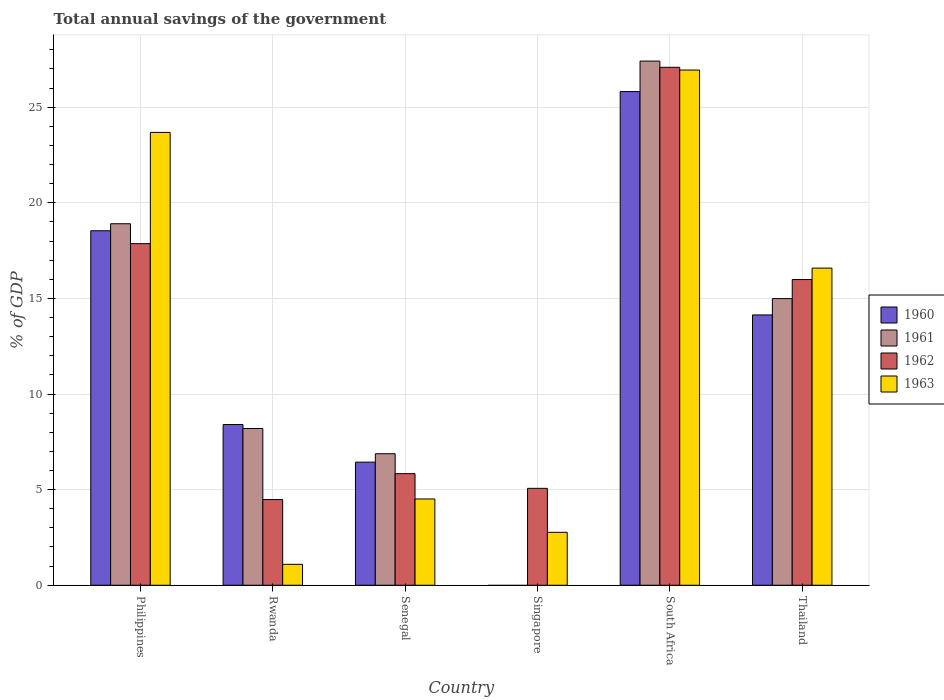How many different coloured bars are there?
Offer a terse response. 4. How many groups of bars are there?
Your answer should be very brief. 6. Are the number of bars on each tick of the X-axis equal?
Your answer should be very brief. No. How many bars are there on the 5th tick from the right?
Provide a succinct answer. 4. What is the label of the 5th group of bars from the left?
Ensure brevity in your answer.  South Africa. In how many cases, is the number of bars for a given country not equal to the number of legend labels?
Your response must be concise. 1. What is the total annual savings of the government in 1962 in Singapore?
Offer a terse response. 5.07. Across all countries, what is the maximum total annual savings of the government in 1962?
Your answer should be very brief. 27.08. Across all countries, what is the minimum total annual savings of the government in 1963?
Give a very brief answer. 1.09. In which country was the total annual savings of the government in 1961 maximum?
Offer a very short reply. South Africa. What is the total total annual savings of the government in 1963 in the graph?
Make the answer very short. 75.57. What is the difference between the total annual savings of the government in 1960 in Philippines and that in Senegal?
Your response must be concise. 12.1. What is the difference between the total annual savings of the government in 1961 in Singapore and the total annual savings of the government in 1960 in Rwanda?
Offer a very short reply. -8.4. What is the average total annual savings of the government in 1960 per country?
Make the answer very short. 12.22. What is the difference between the total annual savings of the government of/in 1961 and total annual savings of the government of/in 1962 in South Africa?
Your answer should be very brief. 0.33. What is the ratio of the total annual savings of the government in 1960 in Philippines to that in Thailand?
Provide a short and direct response. 1.31. Is the total annual savings of the government in 1961 in Philippines less than that in Rwanda?
Ensure brevity in your answer.  No. Is the difference between the total annual savings of the government in 1961 in Rwanda and Senegal greater than the difference between the total annual savings of the government in 1962 in Rwanda and Senegal?
Make the answer very short. Yes. What is the difference between the highest and the second highest total annual savings of the government in 1961?
Your response must be concise. -8.51. What is the difference between the highest and the lowest total annual savings of the government in 1962?
Keep it short and to the point. 22.6. In how many countries, is the total annual savings of the government in 1962 greater than the average total annual savings of the government in 1962 taken over all countries?
Your answer should be very brief. 3. Is the sum of the total annual savings of the government in 1962 in Rwanda and South Africa greater than the maximum total annual savings of the government in 1960 across all countries?
Keep it short and to the point. Yes. Is it the case that in every country, the sum of the total annual savings of the government in 1962 and total annual savings of the government in 1961 is greater than the sum of total annual savings of the government in 1963 and total annual savings of the government in 1960?
Offer a very short reply. No. How many bars are there?
Make the answer very short. 22. Are all the bars in the graph horizontal?
Provide a succinct answer. No. Does the graph contain any zero values?
Give a very brief answer. Yes. Does the graph contain grids?
Your answer should be very brief. Yes. How many legend labels are there?
Your answer should be compact. 4. What is the title of the graph?
Your response must be concise. Total annual savings of the government. Does "2002" appear as one of the legend labels in the graph?
Give a very brief answer. No. What is the label or title of the Y-axis?
Ensure brevity in your answer.  % of GDP. What is the % of GDP of 1960 in Philippines?
Your response must be concise. 18.54. What is the % of GDP of 1961 in Philippines?
Provide a short and direct response. 18.9. What is the % of GDP of 1962 in Philippines?
Your answer should be very brief. 17.86. What is the % of GDP of 1963 in Philippines?
Your answer should be compact. 23.68. What is the % of GDP of 1960 in Rwanda?
Provide a short and direct response. 8.4. What is the % of GDP of 1961 in Rwanda?
Your answer should be compact. 8.2. What is the % of GDP of 1962 in Rwanda?
Keep it short and to the point. 4.48. What is the % of GDP in 1963 in Rwanda?
Your response must be concise. 1.09. What is the % of GDP of 1960 in Senegal?
Give a very brief answer. 6.44. What is the % of GDP in 1961 in Senegal?
Ensure brevity in your answer.  6.88. What is the % of GDP in 1962 in Senegal?
Offer a very short reply. 5.83. What is the % of GDP of 1963 in Senegal?
Offer a very short reply. 4.51. What is the % of GDP in 1960 in Singapore?
Your answer should be very brief. 0. What is the % of GDP of 1961 in Singapore?
Keep it short and to the point. 0. What is the % of GDP of 1962 in Singapore?
Keep it short and to the point. 5.07. What is the % of GDP in 1963 in Singapore?
Ensure brevity in your answer.  2.77. What is the % of GDP in 1960 in South Africa?
Keep it short and to the point. 25.81. What is the % of GDP of 1961 in South Africa?
Offer a very short reply. 27.41. What is the % of GDP of 1962 in South Africa?
Give a very brief answer. 27.08. What is the % of GDP of 1963 in South Africa?
Ensure brevity in your answer.  26.94. What is the % of GDP in 1960 in Thailand?
Provide a succinct answer. 14.13. What is the % of GDP in 1961 in Thailand?
Offer a very short reply. 14.99. What is the % of GDP in 1962 in Thailand?
Provide a short and direct response. 15.99. What is the % of GDP in 1963 in Thailand?
Your response must be concise. 16.58. Across all countries, what is the maximum % of GDP in 1960?
Your answer should be compact. 25.81. Across all countries, what is the maximum % of GDP in 1961?
Ensure brevity in your answer.  27.41. Across all countries, what is the maximum % of GDP in 1962?
Your answer should be very brief. 27.08. Across all countries, what is the maximum % of GDP of 1963?
Your response must be concise. 26.94. Across all countries, what is the minimum % of GDP in 1960?
Give a very brief answer. 0. Across all countries, what is the minimum % of GDP in 1961?
Give a very brief answer. 0. Across all countries, what is the minimum % of GDP in 1962?
Your response must be concise. 4.48. Across all countries, what is the minimum % of GDP of 1963?
Offer a terse response. 1.09. What is the total % of GDP of 1960 in the graph?
Offer a very short reply. 73.33. What is the total % of GDP of 1961 in the graph?
Offer a very short reply. 76.37. What is the total % of GDP of 1962 in the graph?
Provide a short and direct response. 76.31. What is the total % of GDP of 1963 in the graph?
Your answer should be compact. 75.57. What is the difference between the % of GDP of 1960 in Philippines and that in Rwanda?
Give a very brief answer. 10.13. What is the difference between the % of GDP in 1961 in Philippines and that in Rwanda?
Make the answer very short. 10.71. What is the difference between the % of GDP of 1962 in Philippines and that in Rwanda?
Ensure brevity in your answer.  13.38. What is the difference between the % of GDP of 1963 in Philippines and that in Rwanda?
Offer a terse response. 22.58. What is the difference between the % of GDP in 1960 in Philippines and that in Senegal?
Provide a short and direct response. 12.1. What is the difference between the % of GDP of 1961 in Philippines and that in Senegal?
Ensure brevity in your answer.  12.03. What is the difference between the % of GDP of 1962 in Philippines and that in Senegal?
Give a very brief answer. 12.03. What is the difference between the % of GDP in 1963 in Philippines and that in Senegal?
Provide a short and direct response. 19.17. What is the difference between the % of GDP in 1962 in Philippines and that in Singapore?
Provide a short and direct response. 12.79. What is the difference between the % of GDP of 1963 in Philippines and that in Singapore?
Provide a succinct answer. 20.91. What is the difference between the % of GDP of 1960 in Philippines and that in South Africa?
Provide a succinct answer. -7.28. What is the difference between the % of GDP of 1961 in Philippines and that in South Africa?
Give a very brief answer. -8.51. What is the difference between the % of GDP in 1962 in Philippines and that in South Africa?
Your answer should be compact. -9.22. What is the difference between the % of GDP in 1963 in Philippines and that in South Africa?
Keep it short and to the point. -3.26. What is the difference between the % of GDP in 1960 in Philippines and that in Thailand?
Provide a short and direct response. 4.4. What is the difference between the % of GDP of 1961 in Philippines and that in Thailand?
Offer a very short reply. 3.91. What is the difference between the % of GDP of 1962 in Philippines and that in Thailand?
Offer a very short reply. 1.88. What is the difference between the % of GDP of 1963 in Philippines and that in Thailand?
Provide a succinct answer. 7.09. What is the difference between the % of GDP in 1960 in Rwanda and that in Senegal?
Give a very brief answer. 1.97. What is the difference between the % of GDP in 1961 in Rwanda and that in Senegal?
Your response must be concise. 1.32. What is the difference between the % of GDP in 1962 in Rwanda and that in Senegal?
Provide a succinct answer. -1.35. What is the difference between the % of GDP of 1963 in Rwanda and that in Senegal?
Give a very brief answer. -3.42. What is the difference between the % of GDP in 1962 in Rwanda and that in Singapore?
Offer a very short reply. -0.59. What is the difference between the % of GDP in 1963 in Rwanda and that in Singapore?
Offer a very short reply. -1.67. What is the difference between the % of GDP of 1960 in Rwanda and that in South Africa?
Offer a very short reply. -17.41. What is the difference between the % of GDP of 1961 in Rwanda and that in South Africa?
Provide a short and direct response. -19.21. What is the difference between the % of GDP in 1962 in Rwanda and that in South Africa?
Ensure brevity in your answer.  -22.6. What is the difference between the % of GDP of 1963 in Rwanda and that in South Africa?
Make the answer very short. -25.85. What is the difference between the % of GDP in 1960 in Rwanda and that in Thailand?
Offer a terse response. -5.73. What is the difference between the % of GDP of 1961 in Rwanda and that in Thailand?
Give a very brief answer. -6.79. What is the difference between the % of GDP of 1962 in Rwanda and that in Thailand?
Provide a succinct answer. -11.51. What is the difference between the % of GDP in 1963 in Rwanda and that in Thailand?
Your answer should be very brief. -15.49. What is the difference between the % of GDP of 1962 in Senegal and that in Singapore?
Your answer should be very brief. 0.77. What is the difference between the % of GDP of 1963 in Senegal and that in Singapore?
Your answer should be very brief. 1.74. What is the difference between the % of GDP in 1960 in Senegal and that in South Africa?
Offer a very short reply. -19.38. What is the difference between the % of GDP in 1961 in Senegal and that in South Africa?
Your answer should be compact. -20.53. What is the difference between the % of GDP of 1962 in Senegal and that in South Africa?
Your answer should be very brief. -21.25. What is the difference between the % of GDP in 1963 in Senegal and that in South Africa?
Give a very brief answer. -22.43. What is the difference between the % of GDP in 1960 in Senegal and that in Thailand?
Your answer should be compact. -7.7. What is the difference between the % of GDP of 1961 in Senegal and that in Thailand?
Your response must be concise. -8.11. What is the difference between the % of GDP of 1962 in Senegal and that in Thailand?
Your answer should be very brief. -10.15. What is the difference between the % of GDP of 1963 in Senegal and that in Thailand?
Provide a short and direct response. -12.07. What is the difference between the % of GDP of 1962 in Singapore and that in South Africa?
Offer a terse response. -22.02. What is the difference between the % of GDP of 1963 in Singapore and that in South Africa?
Give a very brief answer. -24.17. What is the difference between the % of GDP in 1962 in Singapore and that in Thailand?
Offer a very short reply. -10.92. What is the difference between the % of GDP in 1963 in Singapore and that in Thailand?
Offer a terse response. -13.82. What is the difference between the % of GDP of 1960 in South Africa and that in Thailand?
Offer a very short reply. 11.68. What is the difference between the % of GDP in 1961 in South Africa and that in Thailand?
Provide a short and direct response. 12.42. What is the difference between the % of GDP of 1962 in South Africa and that in Thailand?
Ensure brevity in your answer.  11.1. What is the difference between the % of GDP in 1963 in South Africa and that in Thailand?
Your answer should be very brief. 10.36. What is the difference between the % of GDP of 1960 in Philippines and the % of GDP of 1961 in Rwanda?
Your answer should be compact. 10.34. What is the difference between the % of GDP of 1960 in Philippines and the % of GDP of 1962 in Rwanda?
Offer a very short reply. 14.06. What is the difference between the % of GDP of 1960 in Philippines and the % of GDP of 1963 in Rwanda?
Your answer should be very brief. 17.44. What is the difference between the % of GDP in 1961 in Philippines and the % of GDP in 1962 in Rwanda?
Provide a short and direct response. 14.42. What is the difference between the % of GDP of 1961 in Philippines and the % of GDP of 1963 in Rwanda?
Keep it short and to the point. 17.81. What is the difference between the % of GDP of 1962 in Philippines and the % of GDP of 1963 in Rwanda?
Your answer should be compact. 16.77. What is the difference between the % of GDP in 1960 in Philippines and the % of GDP in 1961 in Senegal?
Offer a terse response. 11.66. What is the difference between the % of GDP in 1960 in Philippines and the % of GDP in 1962 in Senegal?
Give a very brief answer. 12.7. What is the difference between the % of GDP of 1960 in Philippines and the % of GDP of 1963 in Senegal?
Provide a succinct answer. 14.03. What is the difference between the % of GDP of 1961 in Philippines and the % of GDP of 1962 in Senegal?
Make the answer very short. 13.07. What is the difference between the % of GDP of 1961 in Philippines and the % of GDP of 1963 in Senegal?
Your answer should be compact. 14.39. What is the difference between the % of GDP in 1962 in Philippines and the % of GDP in 1963 in Senegal?
Your response must be concise. 13.35. What is the difference between the % of GDP in 1960 in Philippines and the % of GDP in 1962 in Singapore?
Keep it short and to the point. 13.47. What is the difference between the % of GDP of 1960 in Philippines and the % of GDP of 1963 in Singapore?
Your response must be concise. 15.77. What is the difference between the % of GDP of 1961 in Philippines and the % of GDP of 1962 in Singapore?
Your response must be concise. 13.84. What is the difference between the % of GDP of 1961 in Philippines and the % of GDP of 1963 in Singapore?
Offer a very short reply. 16.14. What is the difference between the % of GDP of 1962 in Philippines and the % of GDP of 1963 in Singapore?
Your answer should be compact. 15.09. What is the difference between the % of GDP in 1960 in Philippines and the % of GDP in 1961 in South Africa?
Give a very brief answer. -8.87. What is the difference between the % of GDP in 1960 in Philippines and the % of GDP in 1962 in South Africa?
Your answer should be compact. -8.55. What is the difference between the % of GDP in 1960 in Philippines and the % of GDP in 1963 in South Africa?
Give a very brief answer. -8.4. What is the difference between the % of GDP of 1961 in Philippines and the % of GDP of 1962 in South Africa?
Your answer should be compact. -8.18. What is the difference between the % of GDP in 1961 in Philippines and the % of GDP in 1963 in South Africa?
Offer a very short reply. -8.04. What is the difference between the % of GDP in 1962 in Philippines and the % of GDP in 1963 in South Africa?
Your response must be concise. -9.08. What is the difference between the % of GDP of 1960 in Philippines and the % of GDP of 1961 in Thailand?
Offer a very short reply. 3.55. What is the difference between the % of GDP in 1960 in Philippines and the % of GDP in 1962 in Thailand?
Your answer should be very brief. 2.55. What is the difference between the % of GDP in 1960 in Philippines and the % of GDP in 1963 in Thailand?
Offer a very short reply. 1.95. What is the difference between the % of GDP of 1961 in Philippines and the % of GDP of 1962 in Thailand?
Offer a terse response. 2.92. What is the difference between the % of GDP in 1961 in Philippines and the % of GDP in 1963 in Thailand?
Provide a short and direct response. 2.32. What is the difference between the % of GDP in 1962 in Philippines and the % of GDP in 1963 in Thailand?
Offer a terse response. 1.28. What is the difference between the % of GDP in 1960 in Rwanda and the % of GDP in 1961 in Senegal?
Ensure brevity in your answer.  1.53. What is the difference between the % of GDP in 1960 in Rwanda and the % of GDP in 1962 in Senegal?
Provide a short and direct response. 2.57. What is the difference between the % of GDP of 1960 in Rwanda and the % of GDP of 1963 in Senegal?
Your answer should be compact. 3.89. What is the difference between the % of GDP in 1961 in Rwanda and the % of GDP in 1962 in Senegal?
Offer a terse response. 2.36. What is the difference between the % of GDP of 1961 in Rwanda and the % of GDP of 1963 in Senegal?
Offer a terse response. 3.69. What is the difference between the % of GDP in 1962 in Rwanda and the % of GDP in 1963 in Senegal?
Give a very brief answer. -0.03. What is the difference between the % of GDP of 1960 in Rwanda and the % of GDP of 1962 in Singapore?
Your answer should be compact. 3.34. What is the difference between the % of GDP of 1960 in Rwanda and the % of GDP of 1963 in Singapore?
Ensure brevity in your answer.  5.64. What is the difference between the % of GDP of 1961 in Rwanda and the % of GDP of 1962 in Singapore?
Keep it short and to the point. 3.13. What is the difference between the % of GDP in 1961 in Rwanda and the % of GDP in 1963 in Singapore?
Ensure brevity in your answer.  5.43. What is the difference between the % of GDP of 1962 in Rwanda and the % of GDP of 1963 in Singapore?
Your answer should be compact. 1.71. What is the difference between the % of GDP of 1960 in Rwanda and the % of GDP of 1961 in South Africa?
Ensure brevity in your answer.  -19.01. What is the difference between the % of GDP in 1960 in Rwanda and the % of GDP in 1962 in South Africa?
Offer a very short reply. -18.68. What is the difference between the % of GDP in 1960 in Rwanda and the % of GDP in 1963 in South Africa?
Your response must be concise. -18.54. What is the difference between the % of GDP of 1961 in Rwanda and the % of GDP of 1962 in South Africa?
Make the answer very short. -18.89. What is the difference between the % of GDP in 1961 in Rwanda and the % of GDP in 1963 in South Africa?
Your answer should be compact. -18.74. What is the difference between the % of GDP of 1962 in Rwanda and the % of GDP of 1963 in South Africa?
Your response must be concise. -22.46. What is the difference between the % of GDP of 1960 in Rwanda and the % of GDP of 1961 in Thailand?
Provide a short and direct response. -6.59. What is the difference between the % of GDP of 1960 in Rwanda and the % of GDP of 1962 in Thailand?
Offer a terse response. -7.58. What is the difference between the % of GDP of 1960 in Rwanda and the % of GDP of 1963 in Thailand?
Give a very brief answer. -8.18. What is the difference between the % of GDP in 1961 in Rwanda and the % of GDP in 1962 in Thailand?
Your response must be concise. -7.79. What is the difference between the % of GDP of 1961 in Rwanda and the % of GDP of 1963 in Thailand?
Your answer should be very brief. -8.39. What is the difference between the % of GDP of 1962 in Rwanda and the % of GDP of 1963 in Thailand?
Provide a succinct answer. -12.1. What is the difference between the % of GDP in 1960 in Senegal and the % of GDP in 1962 in Singapore?
Provide a short and direct response. 1.37. What is the difference between the % of GDP in 1960 in Senegal and the % of GDP in 1963 in Singapore?
Make the answer very short. 3.67. What is the difference between the % of GDP of 1961 in Senegal and the % of GDP of 1962 in Singapore?
Offer a terse response. 1.81. What is the difference between the % of GDP of 1961 in Senegal and the % of GDP of 1963 in Singapore?
Offer a very short reply. 4.11. What is the difference between the % of GDP in 1962 in Senegal and the % of GDP in 1963 in Singapore?
Keep it short and to the point. 3.07. What is the difference between the % of GDP of 1960 in Senegal and the % of GDP of 1961 in South Africa?
Give a very brief answer. -20.97. What is the difference between the % of GDP of 1960 in Senegal and the % of GDP of 1962 in South Africa?
Keep it short and to the point. -20.65. What is the difference between the % of GDP of 1960 in Senegal and the % of GDP of 1963 in South Africa?
Your answer should be compact. -20.5. What is the difference between the % of GDP of 1961 in Senegal and the % of GDP of 1962 in South Africa?
Your answer should be very brief. -20.21. What is the difference between the % of GDP of 1961 in Senegal and the % of GDP of 1963 in South Africa?
Your response must be concise. -20.06. What is the difference between the % of GDP in 1962 in Senegal and the % of GDP in 1963 in South Africa?
Make the answer very short. -21.11. What is the difference between the % of GDP in 1960 in Senegal and the % of GDP in 1961 in Thailand?
Offer a very short reply. -8.55. What is the difference between the % of GDP of 1960 in Senegal and the % of GDP of 1962 in Thailand?
Provide a short and direct response. -9.55. What is the difference between the % of GDP in 1960 in Senegal and the % of GDP in 1963 in Thailand?
Ensure brevity in your answer.  -10.15. What is the difference between the % of GDP in 1961 in Senegal and the % of GDP in 1962 in Thailand?
Make the answer very short. -9.11. What is the difference between the % of GDP in 1961 in Senegal and the % of GDP in 1963 in Thailand?
Your answer should be compact. -9.71. What is the difference between the % of GDP in 1962 in Senegal and the % of GDP in 1963 in Thailand?
Keep it short and to the point. -10.75. What is the difference between the % of GDP of 1962 in Singapore and the % of GDP of 1963 in South Africa?
Keep it short and to the point. -21.87. What is the difference between the % of GDP in 1962 in Singapore and the % of GDP in 1963 in Thailand?
Make the answer very short. -11.52. What is the difference between the % of GDP in 1960 in South Africa and the % of GDP in 1961 in Thailand?
Offer a terse response. 10.83. What is the difference between the % of GDP of 1960 in South Africa and the % of GDP of 1962 in Thailand?
Your response must be concise. 9.83. What is the difference between the % of GDP of 1960 in South Africa and the % of GDP of 1963 in Thailand?
Your response must be concise. 9.23. What is the difference between the % of GDP in 1961 in South Africa and the % of GDP in 1962 in Thailand?
Your answer should be very brief. 11.42. What is the difference between the % of GDP of 1961 in South Africa and the % of GDP of 1963 in Thailand?
Your response must be concise. 10.82. What is the difference between the % of GDP in 1962 in South Africa and the % of GDP in 1963 in Thailand?
Keep it short and to the point. 10.5. What is the average % of GDP of 1960 per country?
Provide a short and direct response. 12.22. What is the average % of GDP of 1961 per country?
Offer a very short reply. 12.73. What is the average % of GDP of 1962 per country?
Your response must be concise. 12.72. What is the average % of GDP in 1963 per country?
Offer a terse response. 12.6. What is the difference between the % of GDP of 1960 and % of GDP of 1961 in Philippines?
Give a very brief answer. -0.37. What is the difference between the % of GDP of 1960 and % of GDP of 1962 in Philippines?
Keep it short and to the point. 0.67. What is the difference between the % of GDP in 1960 and % of GDP in 1963 in Philippines?
Make the answer very short. -5.14. What is the difference between the % of GDP of 1961 and % of GDP of 1962 in Philippines?
Keep it short and to the point. 1.04. What is the difference between the % of GDP of 1961 and % of GDP of 1963 in Philippines?
Ensure brevity in your answer.  -4.78. What is the difference between the % of GDP in 1962 and % of GDP in 1963 in Philippines?
Give a very brief answer. -5.82. What is the difference between the % of GDP of 1960 and % of GDP of 1961 in Rwanda?
Offer a very short reply. 0.21. What is the difference between the % of GDP of 1960 and % of GDP of 1962 in Rwanda?
Offer a terse response. 3.92. What is the difference between the % of GDP in 1960 and % of GDP in 1963 in Rwanda?
Keep it short and to the point. 7.31. What is the difference between the % of GDP of 1961 and % of GDP of 1962 in Rwanda?
Provide a succinct answer. 3.72. What is the difference between the % of GDP of 1961 and % of GDP of 1963 in Rwanda?
Your answer should be very brief. 7.1. What is the difference between the % of GDP in 1962 and % of GDP in 1963 in Rwanda?
Provide a short and direct response. 3.39. What is the difference between the % of GDP in 1960 and % of GDP in 1961 in Senegal?
Your answer should be very brief. -0.44. What is the difference between the % of GDP in 1960 and % of GDP in 1962 in Senegal?
Offer a terse response. 0.6. What is the difference between the % of GDP of 1960 and % of GDP of 1963 in Senegal?
Make the answer very short. 1.93. What is the difference between the % of GDP of 1961 and % of GDP of 1962 in Senegal?
Offer a terse response. 1.04. What is the difference between the % of GDP of 1961 and % of GDP of 1963 in Senegal?
Ensure brevity in your answer.  2.37. What is the difference between the % of GDP in 1962 and % of GDP in 1963 in Senegal?
Your answer should be compact. 1.32. What is the difference between the % of GDP of 1962 and % of GDP of 1963 in Singapore?
Make the answer very short. 2.3. What is the difference between the % of GDP of 1960 and % of GDP of 1961 in South Africa?
Offer a very short reply. -1.59. What is the difference between the % of GDP in 1960 and % of GDP in 1962 in South Africa?
Offer a very short reply. -1.27. What is the difference between the % of GDP in 1960 and % of GDP in 1963 in South Africa?
Keep it short and to the point. -1.13. What is the difference between the % of GDP in 1961 and % of GDP in 1962 in South Africa?
Offer a terse response. 0.33. What is the difference between the % of GDP in 1961 and % of GDP in 1963 in South Africa?
Your answer should be very brief. 0.47. What is the difference between the % of GDP in 1962 and % of GDP in 1963 in South Africa?
Keep it short and to the point. 0.14. What is the difference between the % of GDP in 1960 and % of GDP in 1961 in Thailand?
Your answer should be compact. -0.85. What is the difference between the % of GDP of 1960 and % of GDP of 1962 in Thailand?
Provide a succinct answer. -1.85. What is the difference between the % of GDP of 1960 and % of GDP of 1963 in Thailand?
Ensure brevity in your answer.  -2.45. What is the difference between the % of GDP in 1961 and % of GDP in 1962 in Thailand?
Give a very brief answer. -1. What is the difference between the % of GDP of 1961 and % of GDP of 1963 in Thailand?
Offer a terse response. -1.59. What is the difference between the % of GDP in 1962 and % of GDP in 1963 in Thailand?
Your answer should be very brief. -0.6. What is the ratio of the % of GDP in 1960 in Philippines to that in Rwanda?
Your answer should be very brief. 2.21. What is the ratio of the % of GDP of 1961 in Philippines to that in Rwanda?
Make the answer very short. 2.31. What is the ratio of the % of GDP in 1962 in Philippines to that in Rwanda?
Your response must be concise. 3.99. What is the ratio of the % of GDP of 1963 in Philippines to that in Rwanda?
Keep it short and to the point. 21.65. What is the ratio of the % of GDP of 1960 in Philippines to that in Senegal?
Offer a very short reply. 2.88. What is the ratio of the % of GDP in 1961 in Philippines to that in Senegal?
Make the answer very short. 2.75. What is the ratio of the % of GDP of 1962 in Philippines to that in Senegal?
Your response must be concise. 3.06. What is the ratio of the % of GDP in 1963 in Philippines to that in Senegal?
Provide a short and direct response. 5.25. What is the ratio of the % of GDP of 1962 in Philippines to that in Singapore?
Make the answer very short. 3.53. What is the ratio of the % of GDP in 1963 in Philippines to that in Singapore?
Provide a short and direct response. 8.56. What is the ratio of the % of GDP of 1960 in Philippines to that in South Africa?
Give a very brief answer. 0.72. What is the ratio of the % of GDP of 1961 in Philippines to that in South Africa?
Ensure brevity in your answer.  0.69. What is the ratio of the % of GDP of 1962 in Philippines to that in South Africa?
Your answer should be compact. 0.66. What is the ratio of the % of GDP in 1963 in Philippines to that in South Africa?
Offer a very short reply. 0.88. What is the ratio of the % of GDP of 1960 in Philippines to that in Thailand?
Keep it short and to the point. 1.31. What is the ratio of the % of GDP in 1961 in Philippines to that in Thailand?
Your answer should be compact. 1.26. What is the ratio of the % of GDP of 1962 in Philippines to that in Thailand?
Offer a terse response. 1.12. What is the ratio of the % of GDP in 1963 in Philippines to that in Thailand?
Your answer should be very brief. 1.43. What is the ratio of the % of GDP in 1960 in Rwanda to that in Senegal?
Give a very brief answer. 1.31. What is the ratio of the % of GDP of 1961 in Rwanda to that in Senegal?
Your answer should be very brief. 1.19. What is the ratio of the % of GDP of 1962 in Rwanda to that in Senegal?
Your answer should be very brief. 0.77. What is the ratio of the % of GDP of 1963 in Rwanda to that in Senegal?
Provide a succinct answer. 0.24. What is the ratio of the % of GDP of 1962 in Rwanda to that in Singapore?
Your answer should be compact. 0.88. What is the ratio of the % of GDP of 1963 in Rwanda to that in Singapore?
Provide a short and direct response. 0.4. What is the ratio of the % of GDP of 1960 in Rwanda to that in South Africa?
Your response must be concise. 0.33. What is the ratio of the % of GDP in 1961 in Rwanda to that in South Africa?
Keep it short and to the point. 0.3. What is the ratio of the % of GDP of 1962 in Rwanda to that in South Africa?
Give a very brief answer. 0.17. What is the ratio of the % of GDP in 1963 in Rwanda to that in South Africa?
Offer a very short reply. 0.04. What is the ratio of the % of GDP of 1960 in Rwanda to that in Thailand?
Make the answer very short. 0.59. What is the ratio of the % of GDP in 1961 in Rwanda to that in Thailand?
Provide a short and direct response. 0.55. What is the ratio of the % of GDP of 1962 in Rwanda to that in Thailand?
Provide a short and direct response. 0.28. What is the ratio of the % of GDP of 1963 in Rwanda to that in Thailand?
Your answer should be compact. 0.07. What is the ratio of the % of GDP of 1962 in Senegal to that in Singapore?
Your answer should be compact. 1.15. What is the ratio of the % of GDP of 1963 in Senegal to that in Singapore?
Provide a short and direct response. 1.63. What is the ratio of the % of GDP in 1960 in Senegal to that in South Africa?
Give a very brief answer. 0.25. What is the ratio of the % of GDP of 1961 in Senegal to that in South Africa?
Keep it short and to the point. 0.25. What is the ratio of the % of GDP in 1962 in Senegal to that in South Africa?
Your answer should be very brief. 0.22. What is the ratio of the % of GDP of 1963 in Senegal to that in South Africa?
Make the answer very short. 0.17. What is the ratio of the % of GDP in 1960 in Senegal to that in Thailand?
Provide a short and direct response. 0.46. What is the ratio of the % of GDP in 1961 in Senegal to that in Thailand?
Keep it short and to the point. 0.46. What is the ratio of the % of GDP in 1962 in Senegal to that in Thailand?
Ensure brevity in your answer.  0.36. What is the ratio of the % of GDP in 1963 in Senegal to that in Thailand?
Provide a short and direct response. 0.27. What is the ratio of the % of GDP of 1962 in Singapore to that in South Africa?
Give a very brief answer. 0.19. What is the ratio of the % of GDP in 1963 in Singapore to that in South Africa?
Ensure brevity in your answer.  0.1. What is the ratio of the % of GDP of 1962 in Singapore to that in Thailand?
Keep it short and to the point. 0.32. What is the ratio of the % of GDP in 1963 in Singapore to that in Thailand?
Offer a terse response. 0.17. What is the ratio of the % of GDP in 1960 in South Africa to that in Thailand?
Make the answer very short. 1.83. What is the ratio of the % of GDP in 1961 in South Africa to that in Thailand?
Your response must be concise. 1.83. What is the ratio of the % of GDP in 1962 in South Africa to that in Thailand?
Make the answer very short. 1.69. What is the ratio of the % of GDP in 1963 in South Africa to that in Thailand?
Your response must be concise. 1.62. What is the difference between the highest and the second highest % of GDP in 1960?
Keep it short and to the point. 7.28. What is the difference between the highest and the second highest % of GDP of 1961?
Your answer should be very brief. 8.51. What is the difference between the highest and the second highest % of GDP of 1962?
Make the answer very short. 9.22. What is the difference between the highest and the second highest % of GDP in 1963?
Keep it short and to the point. 3.26. What is the difference between the highest and the lowest % of GDP of 1960?
Offer a terse response. 25.81. What is the difference between the highest and the lowest % of GDP in 1961?
Ensure brevity in your answer.  27.41. What is the difference between the highest and the lowest % of GDP in 1962?
Offer a terse response. 22.6. What is the difference between the highest and the lowest % of GDP in 1963?
Ensure brevity in your answer.  25.85. 